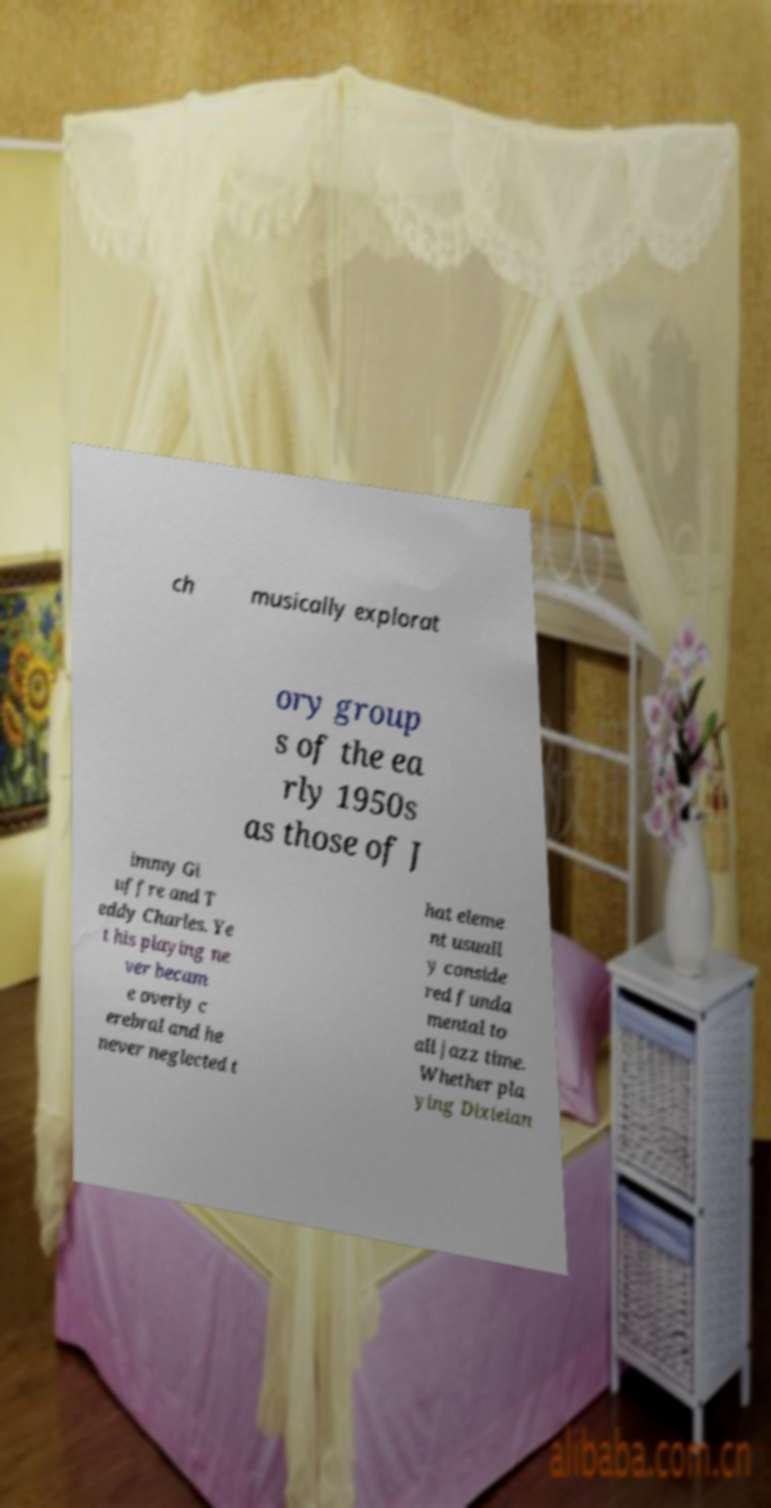What messages or text are displayed in this image? I need them in a readable, typed format. ch musically explorat ory group s of the ea rly 1950s as those of J immy Gi uffre and T eddy Charles. Ye t his playing ne ver becam e overly c erebral and he never neglected t hat eleme nt usuall y conside red funda mental to all jazz time. Whether pla ying Dixielan 